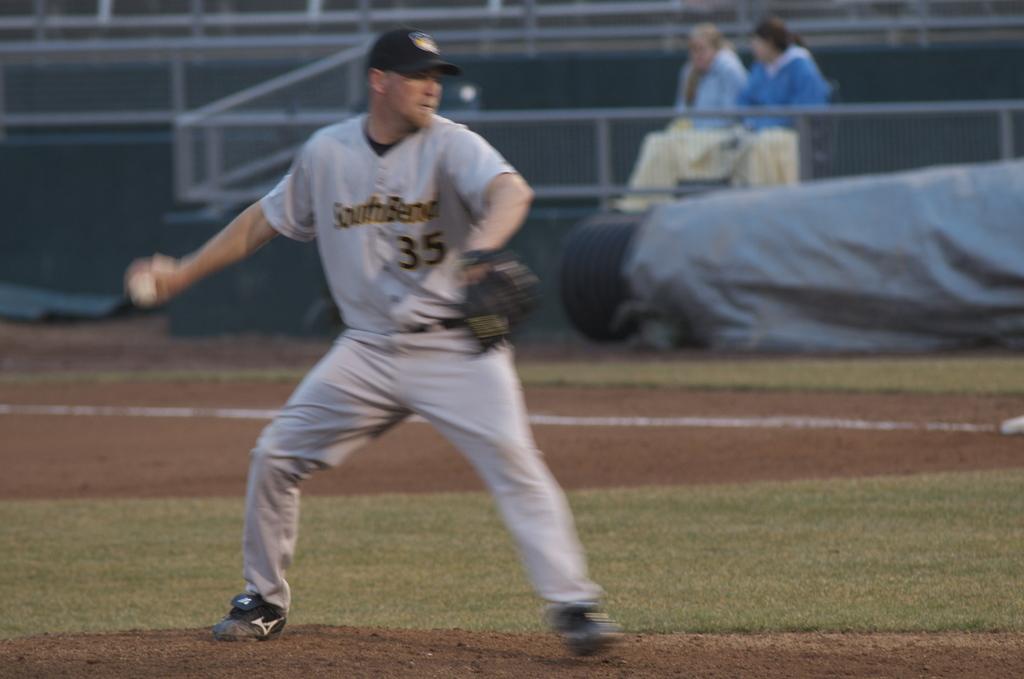What is the player number of this pitcher?
Offer a terse response. 35. Does he play for southbend?
Offer a terse response. Yes. 